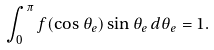Convert formula to latex. <formula><loc_0><loc_0><loc_500><loc_500>\int _ { 0 } ^ { \pi } f ( \cos \theta _ { e } ) \sin \theta _ { e } \, d \theta _ { e } = 1 .</formula> 